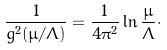Convert formula to latex. <formula><loc_0><loc_0><loc_500><loc_500>\frac { 1 } { g ^ { 2 } ( \mu / \Lambda ) } = \frac { 1 } { 4 \pi ^ { 2 } } \ln \frac { \mu } { \Lambda } \cdot</formula> 